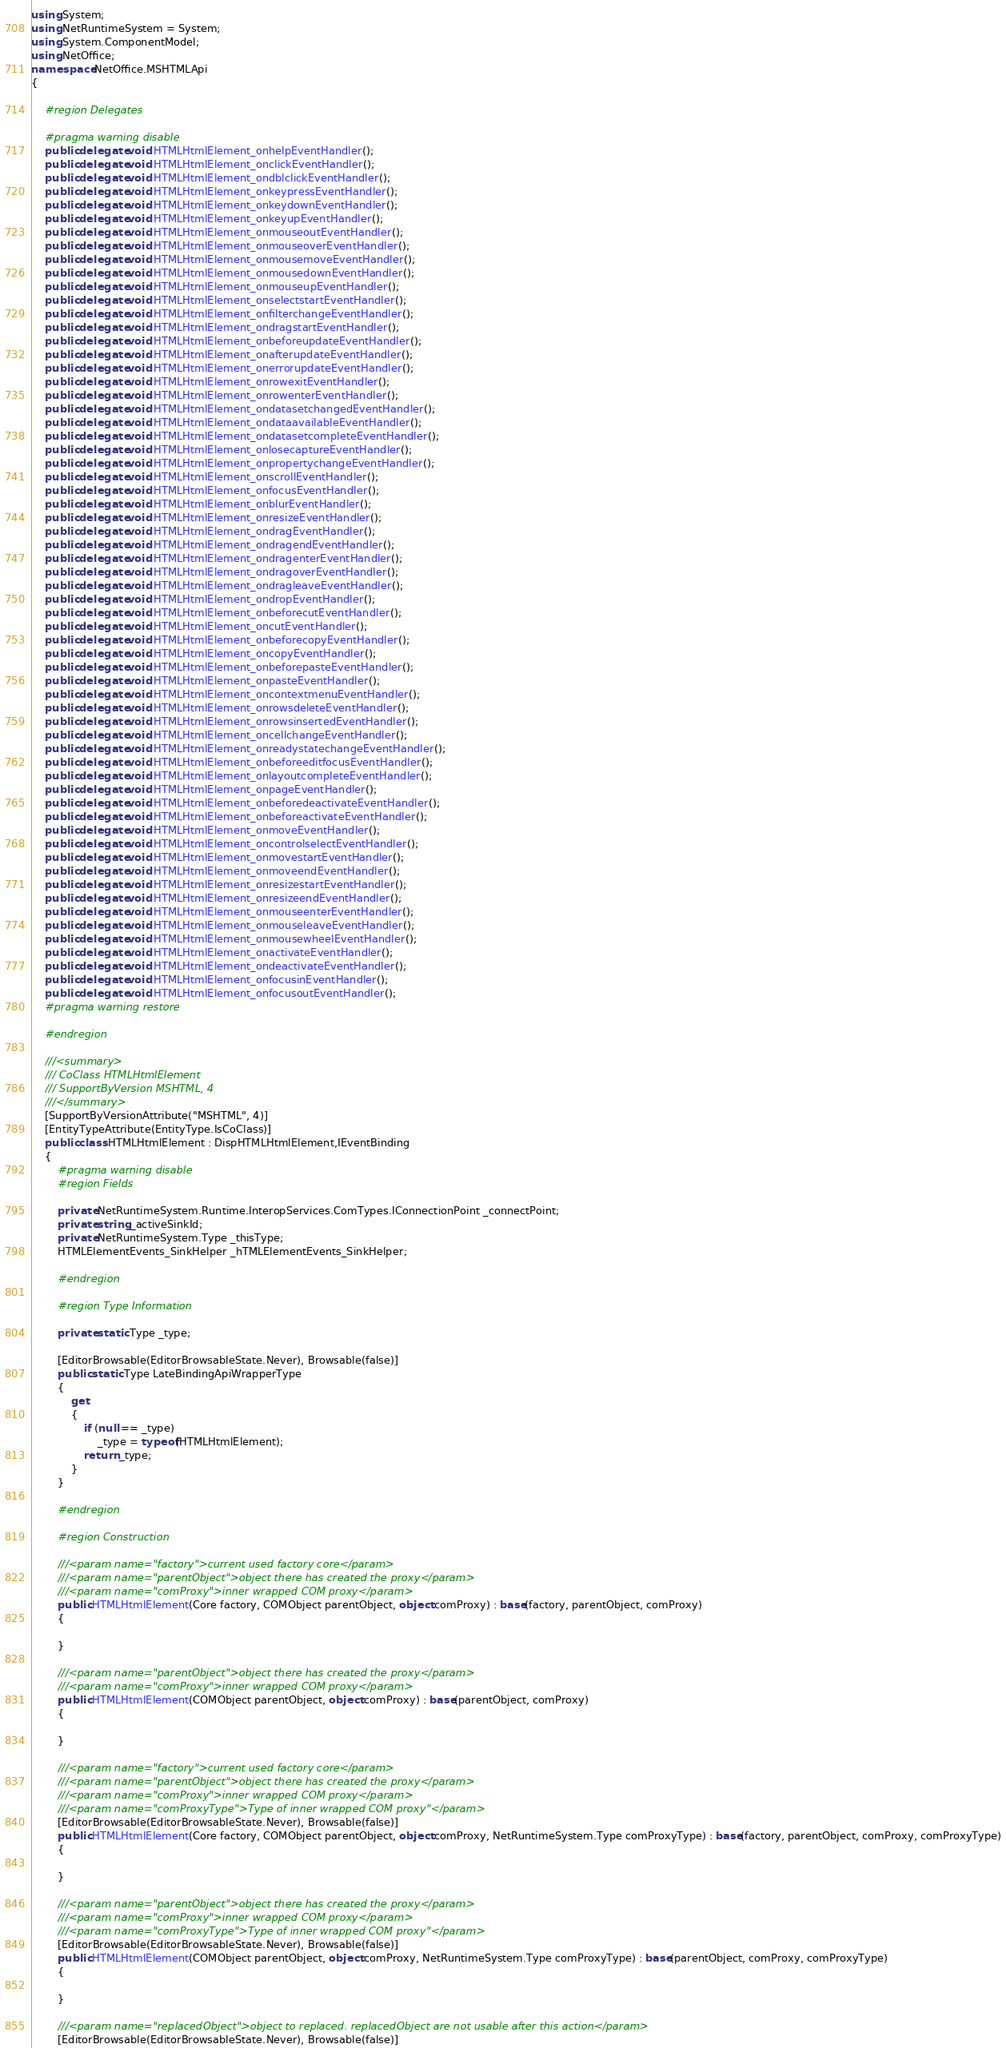Convert code to text. <code><loc_0><loc_0><loc_500><loc_500><_C#_>using System;
using NetRuntimeSystem = System;
using System.ComponentModel;
using NetOffice;
namespace NetOffice.MSHTMLApi
{

	#region Delegates

	#pragma warning disable
	public delegate void HTMLHtmlElement_onhelpEventHandler();
	public delegate void HTMLHtmlElement_onclickEventHandler();
	public delegate void HTMLHtmlElement_ondblclickEventHandler();
	public delegate void HTMLHtmlElement_onkeypressEventHandler();
	public delegate void HTMLHtmlElement_onkeydownEventHandler();
	public delegate void HTMLHtmlElement_onkeyupEventHandler();
	public delegate void HTMLHtmlElement_onmouseoutEventHandler();
	public delegate void HTMLHtmlElement_onmouseoverEventHandler();
	public delegate void HTMLHtmlElement_onmousemoveEventHandler();
	public delegate void HTMLHtmlElement_onmousedownEventHandler();
	public delegate void HTMLHtmlElement_onmouseupEventHandler();
	public delegate void HTMLHtmlElement_onselectstartEventHandler();
	public delegate void HTMLHtmlElement_onfilterchangeEventHandler();
	public delegate void HTMLHtmlElement_ondragstartEventHandler();
	public delegate void HTMLHtmlElement_onbeforeupdateEventHandler();
	public delegate void HTMLHtmlElement_onafterupdateEventHandler();
	public delegate void HTMLHtmlElement_onerrorupdateEventHandler();
	public delegate void HTMLHtmlElement_onrowexitEventHandler();
	public delegate void HTMLHtmlElement_onrowenterEventHandler();
	public delegate void HTMLHtmlElement_ondatasetchangedEventHandler();
	public delegate void HTMLHtmlElement_ondataavailableEventHandler();
	public delegate void HTMLHtmlElement_ondatasetcompleteEventHandler();
	public delegate void HTMLHtmlElement_onlosecaptureEventHandler();
	public delegate void HTMLHtmlElement_onpropertychangeEventHandler();
	public delegate void HTMLHtmlElement_onscrollEventHandler();
	public delegate void HTMLHtmlElement_onfocusEventHandler();
	public delegate void HTMLHtmlElement_onblurEventHandler();
	public delegate void HTMLHtmlElement_onresizeEventHandler();
	public delegate void HTMLHtmlElement_ondragEventHandler();
	public delegate void HTMLHtmlElement_ondragendEventHandler();
	public delegate void HTMLHtmlElement_ondragenterEventHandler();
	public delegate void HTMLHtmlElement_ondragoverEventHandler();
	public delegate void HTMLHtmlElement_ondragleaveEventHandler();
	public delegate void HTMLHtmlElement_ondropEventHandler();
	public delegate void HTMLHtmlElement_onbeforecutEventHandler();
	public delegate void HTMLHtmlElement_oncutEventHandler();
	public delegate void HTMLHtmlElement_onbeforecopyEventHandler();
	public delegate void HTMLHtmlElement_oncopyEventHandler();
	public delegate void HTMLHtmlElement_onbeforepasteEventHandler();
	public delegate void HTMLHtmlElement_onpasteEventHandler();
	public delegate void HTMLHtmlElement_oncontextmenuEventHandler();
	public delegate void HTMLHtmlElement_onrowsdeleteEventHandler();
	public delegate void HTMLHtmlElement_onrowsinsertedEventHandler();
	public delegate void HTMLHtmlElement_oncellchangeEventHandler();
	public delegate void HTMLHtmlElement_onreadystatechangeEventHandler();
	public delegate void HTMLHtmlElement_onbeforeeditfocusEventHandler();
	public delegate void HTMLHtmlElement_onlayoutcompleteEventHandler();
	public delegate void HTMLHtmlElement_onpageEventHandler();
	public delegate void HTMLHtmlElement_onbeforedeactivateEventHandler();
	public delegate void HTMLHtmlElement_onbeforeactivateEventHandler();
	public delegate void HTMLHtmlElement_onmoveEventHandler();
	public delegate void HTMLHtmlElement_oncontrolselectEventHandler();
	public delegate void HTMLHtmlElement_onmovestartEventHandler();
	public delegate void HTMLHtmlElement_onmoveendEventHandler();
	public delegate void HTMLHtmlElement_onresizestartEventHandler();
	public delegate void HTMLHtmlElement_onresizeendEventHandler();
	public delegate void HTMLHtmlElement_onmouseenterEventHandler();
	public delegate void HTMLHtmlElement_onmouseleaveEventHandler();
	public delegate void HTMLHtmlElement_onmousewheelEventHandler();
	public delegate void HTMLHtmlElement_onactivateEventHandler();
	public delegate void HTMLHtmlElement_ondeactivateEventHandler();
	public delegate void HTMLHtmlElement_onfocusinEventHandler();
	public delegate void HTMLHtmlElement_onfocusoutEventHandler();
	#pragma warning restore

	#endregion

	///<summary>
	/// CoClass HTMLHtmlElement 
	/// SupportByVersion MSHTML, 4
	///</summary>
	[SupportByVersionAttribute("MSHTML", 4)]
	[EntityTypeAttribute(EntityType.IsCoClass)]
	public class HTMLHtmlElement : DispHTMLHtmlElement,IEventBinding
	{
		#pragma warning disable
		#region Fields
		
		private NetRuntimeSystem.Runtime.InteropServices.ComTypes.IConnectionPoint _connectPoint;
		private string _activeSinkId;
		private NetRuntimeSystem.Type _thisType;
		HTMLElementEvents_SinkHelper _hTMLElementEvents_SinkHelper;
	
		#endregion

		#region Type Information

        private static Type _type;
		
		[EditorBrowsable(EditorBrowsableState.Never), Browsable(false)]
        public static Type LateBindingApiWrapperType
        {
            get
            {
                if (null == _type)
                    _type = typeof(HTMLHtmlElement);
                return _type;
            }
        }
        
        #endregion
        		
		#region Construction

		///<param name="factory">current used factory core</param>
		///<param name="parentObject">object there has created the proxy</param>
        ///<param name="comProxy">inner wrapped COM proxy</param>
		public HTMLHtmlElement(Core factory, COMObject parentObject, object comProxy) : base(factory, parentObject, comProxy)
		{
			
		}

        ///<param name="parentObject">object there has created the proxy</param>
        ///<param name="comProxy">inner wrapped COM proxy</param>
		public HTMLHtmlElement(COMObject parentObject, object comProxy) : base(parentObject, comProxy)
		{
			
		}

		///<param name="factory">current used factory core</param>
		///<param name="parentObject">object there has created the proxy</param>
        ///<param name="comProxy">inner wrapped COM proxy</param>
        ///<param name="comProxyType">Type of inner wrapped COM proxy"</param>
		[EditorBrowsable(EditorBrowsableState.Never), Browsable(false)]
		public HTMLHtmlElement(Core factory, COMObject parentObject, object comProxy, NetRuntimeSystem.Type comProxyType) : base(factory, parentObject, comProxy, comProxyType)
		{
			
		}

		///<param name="parentObject">object there has created the proxy</param>
        ///<param name="comProxy">inner wrapped COM proxy</param>
        ///<param name="comProxyType">Type of inner wrapped COM proxy"</param>
		[EditorBrowsable(EditorBrowsableState.Never), Browsable(false)]
		public HTMLHtmlElement(COMObject parentObject, object comProxy, NetRuntimeSystem.Type comProxyType) : base(parentObject, comProxy, comProxyType)
		{
			
		}
		
		///<param name="replacedObject">object to replaced. replacedObject are not usable after this action</param>
		[EditorBrowsable(EditorBrowsableState.Never), Browsable(false)]</code> 